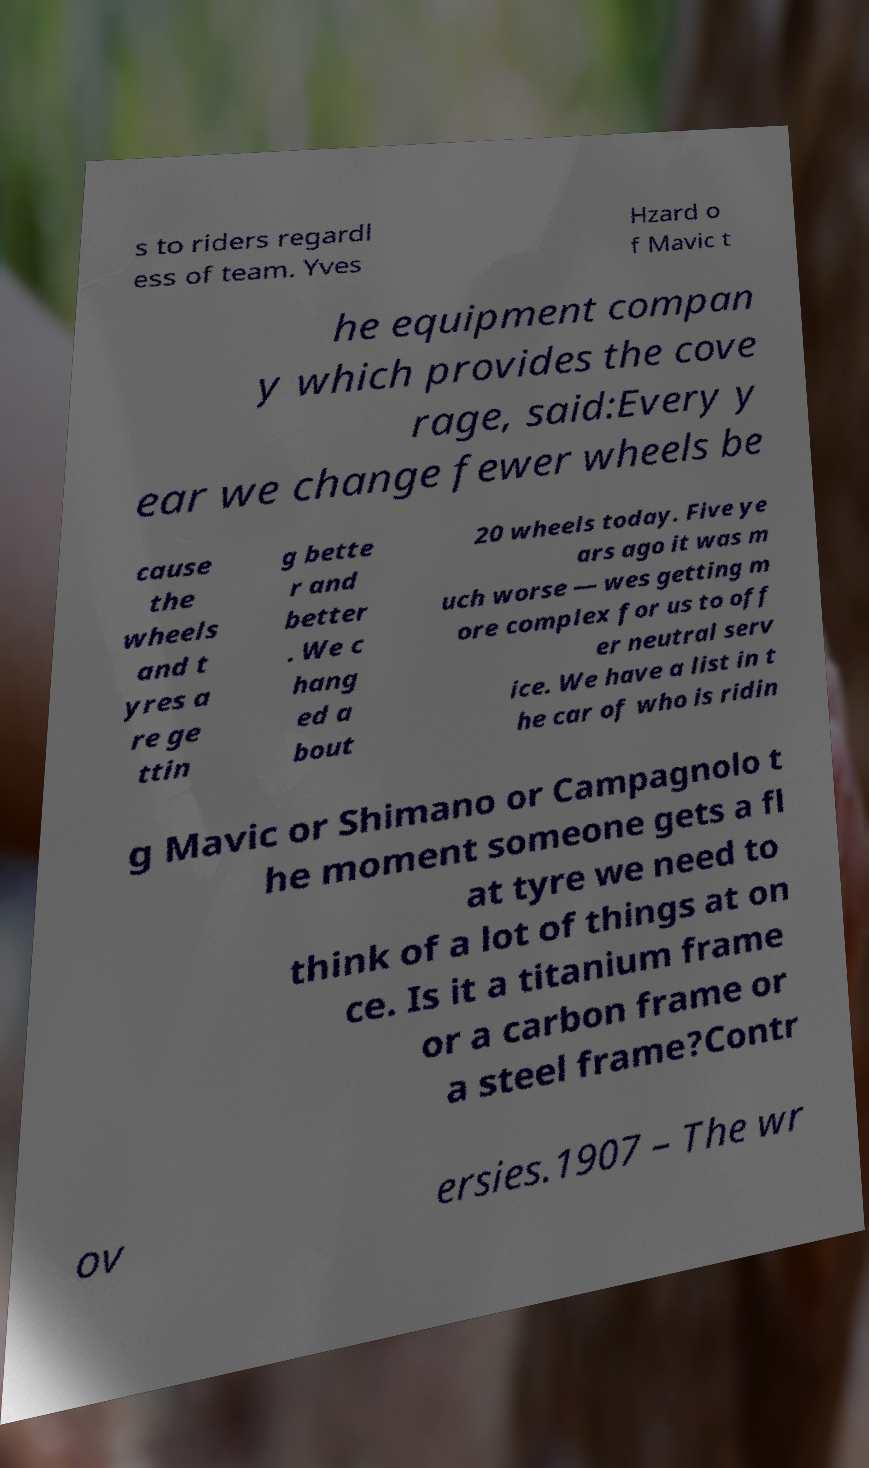For documentation purposes, I need the text within this image transcribed. Could you provide that? s to riders regardl ess of team. Yves Hzard o f Mavic t he equipment compan y which provides the cove rage, said:Every y ear we change fewer wheels be cause the wheels and t yres a re ge ttin g bette r and better . We c hang ed a bout 20 wheels today. Five ye ars ago it was m uch worse — wes getting m ore complex for us to off er neutral serv ice. We have a list in t he car of who is ridin g Mavic or Shimano or Campagnolo t he moment someone gets a fl at tyre we need to think of a lot of things at on ce. Is it a titanium frame or a carbon frame or a steel frame?Contr ov ersies.1907 – The wr 